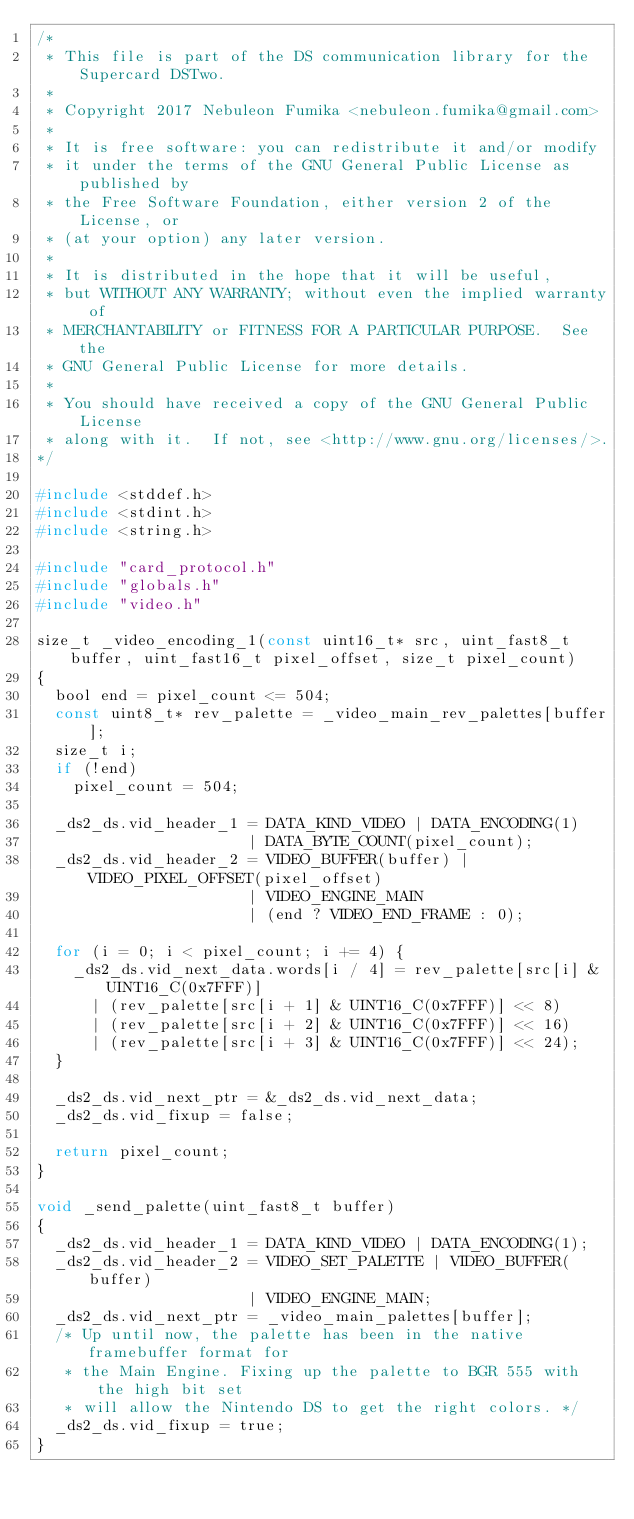<code> <loc_0><loc_0><loc_500><loc_500><_C_>/*
 * This file is part of the DS communication library for the Supercard DSTwo.
 *
 * Copyright 2017 Nebuleon Fumika <nebuleon.fumika@gmail.com>
 *
 * It is free software: you can redistribute it and/or modify
 * it under the terms of the GNU General Public License as published by
 * the Free Software Foundation, either version 2 of the License, or
 * (at your option) any later version.
 *
 * It is distributed in the hope that it will be useful,
 * but WITHOUT ANY WARRANTY; without even the implied warranty of
 * MERCHANTABILITY or FITNESS FOR A PARTICULAR PURPOSE.  See the
 * GNU General Public License for more details.
 *
 * You should have received a copy of the GNU General Public License
 * along with it.  If not, see <http://www.gnu.org/licenses/>.
*/

#include <stddef.h>
#include <stdint.h>
#include <string.h>

#include "card_protocol.h"
#include "globals.h"
#include "video.h"

size_t _video_encoding_1(const uint16_t* src, uint_fast8_t buffer, uint_fast16_t pixel_offset, size_t pixel_count)
{
	bool end = pixel_count <= 504;
	const uint8_t* rev_palette = _video_main_rev_palettes[buffer];
	size_t i;
	if (!end)
		pixel_count = 504;

	_ds2_ds.vid_header_1 = DATA_KIND_VIDEO | DATA_ENCODING(1)
	                     | DATA_BYTE_COUNT(pixel_count);
	_ds2_ds.vid_header_2 = VIDEO_BUFFER(buffer) | VIDEO_PIXEL_OFFSET(pixel_offset)
	                     | VIDEO_ENGINE_MAIN
	                     | (end ? VIDEO_END_FRAME : 0);

	for (i = 0; i < pixel_count; i += 4) {
		_ds2_ds.vid_next_data.words[i / 4] = rev_palette[src[i] & UINT16_C(0x7FFF)]
			| (rev_palette[src[i + 1] & UINT16_C(0x7FFF)] << 8)
			| (rev_palette[src[i + 2] & UINT16_C(0x7FFF)] << 16)
			| (rev_palette[src[i + 3] & UINT16_C(0x7FFF)] << 24);
	}

	_ds2_ds.vid_next_ptr = &_ds2_ds.vid_next_data;
	_ds2_ds.vid_fixup = false;

	return pixel_count;
}

void _send_palette(uint_fast8_t buffer)
{
	_ds2_ds.vid_header_1 = DATA_KIND_VIDEO | DATA_ENCODING(1);
	_ds2_ds.vid_header_2 = VIDEO_SET_PALETTE | VIDEO_BUFFER(buffer)
	                     | VIDEO_ENGINE_MAIN;
	_ds2_ds.vid_next_ptr = _video_main_palettes[buffer];
	/* Up until now, the palette has been in the native framebuffer format for
	 * the Main Engine. Fixing up the palette to BGR 555 with the high bit set
	 * will allow the Nintendo DS to get the right colors. */
	_ds2_ds.vid_fixup = true;
}
</code> 